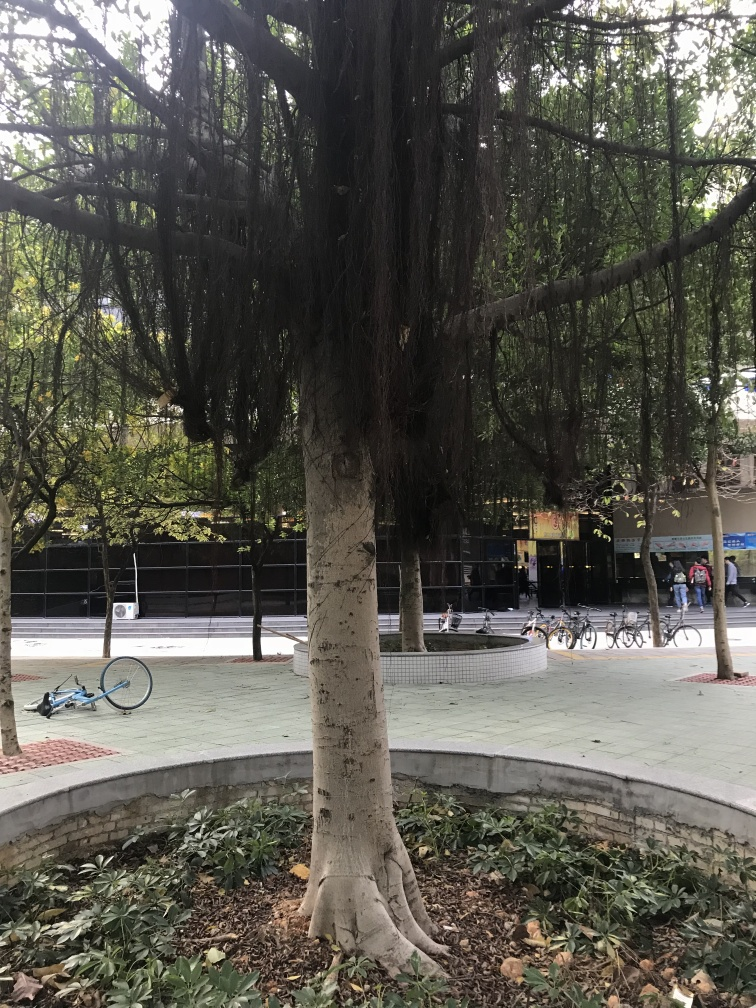Can you tell me what kind of tree this is and any relevant information about it? The tree in the image appears to be a species with a distinctive smooth trunk and buttress roots, which are commonly seen in species like the Kapok or Silk Cotton trees. Such trees are known for their majestic appearance and can be found in tropical regions. They are often important to the local ecosystem for their role in providing shelter and food to various animal species. 